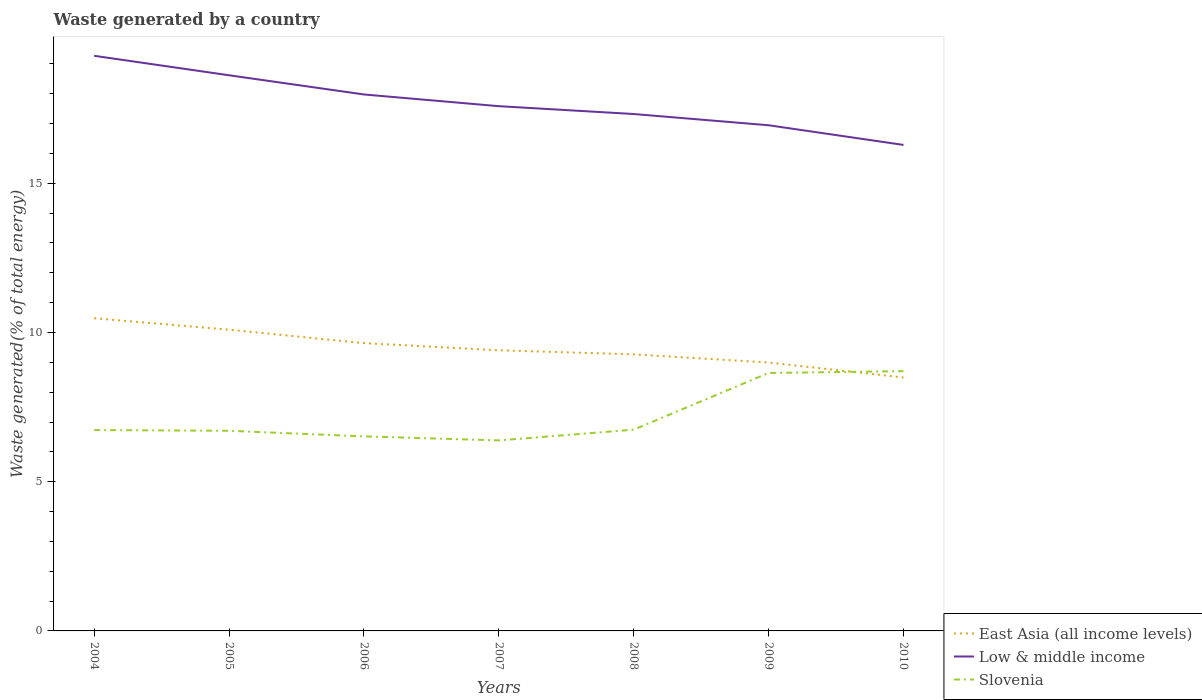Does the line corresponding to East Asia (all income levels) intersect with the line corresponding to Low & middle income?
Your response must be concise. No. Across all years, what is the maximum total waste generated in East Asia (all income levels)?
Your answer should be compact. 8.49. In which year was the total waste generated in Slovenia maximum?
Provide a short and direct response. 2007. What is the total total waste generated in Low & middle income in the graph?
Give a very brief answer. 0.38. What is the difference between the highest and the second highest total waste generated in East Asia (all income levels)?
Your answer should be very brief. 1.99. Is the total waste generated in East Asia (all income levels) strictly greater than the total waste generated in Low & middle income over the years?
Offer a very short reply. Yes. What is the difference between two consecutive major ticks on the Y-axis?
Provide a succinct answer. 5. Are the values on the major ticks of Y-axis written in scientific E-notation?
Make the answer very short. No. Does the graph contain any zero values?
Offer a terse response. No. Does the graph contain grids?
Ensure brevity in your answer.  No. What is the title of the graph?
Ensure brevity in your answer.  Waste generated by a country. Does "Turkey" appear as one of the legend labels in the graph?
Give a very brief answer. No. What is the label or title of the Y-axis?
Your response must be concise. Waste generated(% of total energy). What is the Waste generated(% of total energy) of East Asia (all income levels) in 2004?
Your response must be concise. 10.48. What is the Waste generated(% of total energy) of Low & middle income in 2004?
Ensure brevity in your answer.  19.27. What is the Waste generated(% of total energy) in Slovenia in 2004?
Offer a very short reply. 6.73. What is the Waste generated(% of total energy) of East Asia (all income levels) in 2005?
Ensure brevity in your answer.  10.09. What is the Waste generated(% of total energy) of Low & middle income in 2005?
Your answer should be very brief. 18.62. What is the Waste generated(% of total energy) in Slovenia in 2005?
Provide a succinct answer. 6.71. What is the Waste generated(% of total energy) of East Asia (all income levels) in 2006?
Offer a terse response. 9.64. What is the Waste generated(% of total energy) of Low & middle income in 2006?
Your answer should be very brief. 17.97. What is the Waste generated(% of total energy) of Slovenia in 2006?
Give a very brief answer. 6.52. What is the Waste generated(% of total energy) in East Asia (all income levels) in 2007?
Your response must be concise. 9.4. What is the Waste generated(% of total energy) in Low & middle income in 2007?
Ensure brevity in your answer.  17.58. What is the Waste generated(% of total energy) of Slovenia in 2007?
Make the answer very short. 6.38. What is the Waste generated(% of total energy) in East Asia (all income levels) in 2008?
Offer a terse response. 9.27. What is the Waste generated(% of total energy) of Low & middle income in 2008?
Your answer should be very brief. 17.32. What is the Waste generated(% of total energy) of Slovenia in 2008?
Your answer should be very brief. 6.74. What is the Waste generated(% of total energy) of East Asia (all income levels) in 2009?
Offer a very short reply. 8.99. What is the Waste generated(% of total energy) in Low & middle income in 2009?
Provide a succinct answer. 16.94. What is the Waste generated(% of total energy) of Slovenia in 2009?
Make the answer very short. 8.64. What is the Waste generated(% of total energy) of East Asia (all income levels) in 2010?
Provide a short and direct response. 8.49. What is the Waste generated(% of total energy) of Low & middle income in 2010?
Give a very brief answer. 16.28. What is the Waste generated(% of total energy) of Slovenia in 2010?
Provide a succinct answer. 8.7. Across all years, what is the maximum Waste generated(% of total energy) in East Asia (all income levels)?
Offer a terse response. 10.48. Across all years, what is the maximum Waste generated(% of total energy) in Low & middle income?
Give a very brief answer. 19.27. Across all years, what is the maximum Waste generated(% of total energy) of Slovenia?
Your answer should be compact. 8.7. Across all years, what is the minimum Waste generated(% of total energy) of East Asia (all income levels)?
Your response must be concise. 8.49. Across all years, what is the minimum Waste generated(% of total energy) of Low & middle income?
Offer a terse response. 16.28. Across all years, what is the minimum Waste generated(% of total energy) of Slovenia?
Your answer should be compact. 6.38. What is the total Waste generated(% of total energy) in East Asia (all income levels) in the graph?
Provide a succinct answer. 66.37. What is the total Waste generated(% of total energy) in Low & middle income in the graph?
Make the answer very short. 123.99. What is the total Waste generated(% of total energy) in Slovenia in the graph?
Offer a very short reply. 50.43. What is the difference between the Waste generated(% of total energy) of East Asia (all income levels) in 2004 and that in 2005?
Provide a short and direct response. 0.38. What is the difference between the Waste generated(% of total energy) of Low & middle income in 2004 and that in 2005?
Offer a terse response. 0.65. What is the difference between the Waste generated(% of total energy) of Slovenia in 2004 and that in 2005?
Your answer should be compact. 0.02. What is the difference between the Waste generated(% of total energy) of East Asia (all income levels) in 2004 and that in 2006?
Give a very brief answer. 0.83. What is the difference between the Waste generated(% of total energy) in Low & middle income in 2004 and that in 2006?
Your answer should be compact. 1.3. What is the difference between the Waste generated(% of total energy) of Slovenia in 2004 and that in 2006?
Your response must be concise. 0.21. What is the difference between the Waste generated(% of total energy) of East Asia (all income levels) in 2004 and that in 2007?
Your response must be concise. 1.07. What is the difference between the Waste generated(% of total energy) in Low & middle income in 2004 and that in 2007?
Provide a succinct answer. 1.69. What is the difference between the Waste generated(% of total energy) of Slovenia in 2004 and that in 2007?
Ensure brevity in your answer.  0.35. What is the difference between the Waste generated(% of total energy) in East Asia (all income levels) in 2004 and that in 2008?
Offer a very short reply. 1.21. What is the difference between the Waste generated(% of total energy) of Low & middle income in 2004 and that in 2008?
Provide a succinct answer. 1.95. What is the difference between the Waste generated(% of total energy) of Slovenia in 2004 and that in 2008?
Ensure brevity in your answer.  -0.01. What is the difference between the Waste generated(% of total energy) in East Asia (all income levels) in 2004 and that in 2009?
Keep it short and to the point. 1.48. What is the difference between the Waste generated(% of total energy) in Low & middle income in 2004 and that in 2009?
Make the answer very short. 2.33. What is the difference between the Waste generated(% of total energy) in Slovenia in 2004 and that in 2009?
Your answer should be compact. -1.91. What is the difference between the Waste generated(% of total energy) in East Asia (all income levels) in 2004 and that in 2010?
Offer a very short reply. 1.99. What is the difference between the Waste generated(% of total energy) in Low & middle income in 2004 and that in 2010?
Provide a short and direct response. 2.99. What is the difference between the Waste generated(% of total energy) of Slovenia in 2004 and that in 2010?
Offer a very short reply. -1.97. What is the difference between the Waste generated(% of total energy) in East Asia (all income levels) in 2005 and that in 2006?
Ensure brevity in your answer.  0.45. What is the difference between the Waste generated(% of total energy) in Low & middle income in 2005 and that in 2006?
Your response must be concise. 0.64. What is the difference between the Waste generated(% of total energy) in Slovenia in 2005 and that in 2006?
Give a very brief answer. 0.19. What is the difference between the Waste generated(% of total energy) of East Asia (all income levels) in 2005 and that in 2007?
Keep it short and to the point. 0.69. What is the difference between the Waste generated(% of total energy) of Low & middle income in 2005 and that in 2007?
Offer a terse response. 1.04. What is the difference between the Waste generated(% of total energy) in Slovenia in 2005 and that in 2007?
Offer a terse response. 0.32. What is the difference between the Waste generated(% of total energy) in East Asia (all income levels) in 2005 and that in 2008?
Your answer should be compact. 0.83. What is the difference between the Waste generated(% of total energy) of Low & middle income in 2005 and that in 2008?
Your answer should be very brief. 1.3. What is the difference between the Waste generated(% of total energy) in Slovenia in 2005 and that in 2008?
Make the answer very short. -0.04. What is the difference between the Waste generated(% of total energy) of East Asia (all income levels) in 2005 and that in 2009?
Your answer should be very brief. 1.1. What is the difference between the Waste generated(% of total energy) of Low & middle income in 2005 and that in 2009?
Keep it short and to the point. 1.67. What is the difference between the Waste generated(% of total energy) of Slovenia in 2005 and that in 2009?
Give a very brief answer. -1.94. What is the difference between the Waste generated(% of total energy) in East Asia (all income levels) in 2005 and that in 2010?
Your answer should be compact. 1.6. What is the difference between the Waste generated(% of total energy) in Low & middle income in 2005 and that in 2010?
Offer a very short reply. 2.33. What is the difference between the Waste generated(% of total energy) of Slovenia in 2005 and that in 2010?
Ensure brevity in your answer.  -2. What is the difference between the Waste generated(% of total energy) of East Asia (all income levels) in 2006 and that in 2007?
Provide a short and direct response. 0.24. What is the difference between the Waste generated(% of total energy) of Low & middle income in 2006 and that in 2007?
Give a very brief answer. 0.39. What is the difference between the Waste generated(% of total energy) in Slovenia in 2006 and that in 2007?
Offer a terse response. 0.14. What is the difference between the Waste generated(% of total energy) of East Asia (all income levels) in 2006 and that in 2008?
Keep it short and to the point. 0.38. What is the difference between the Waste generated(% of total energy) of Low & middle income in 2006 and that in 2008?
Offer a terse response. 0.66. What is the difference between the Waste generated(% of total energy) of Slovenia in 2006 and that in 2008?
Provide a succinct answer. -0.23. What is the difference between the Waste generated(% of total energy) of East Asia (all income levels) in 2006 and that in 2009?
Make the answer very short. 0.65. What is the difference between the Waste generated(% of total energy) in Low & middle income in 2006 and that in 2009?
Make the answer very short. 1.03. What is the difference between the Waste generated(% of total energy) of Slovenia in 2006 and that in 2009?
Provide a succinct answer. -2.12. What is the difference between the Waste generated(% of total energy) of East Asia (all income levels) in 2006 and that in 2010?
Provide a short and direct response. 1.15. What is the difference between the Waste generated(% of total energy) of Low & middle income in 2006 and that in 2010?
Give a very brief answer. 1.69. What is the difference between the Waste generated(% of total energy) of Slovenia in 2006 and that in 2010?
Ensure brevity in your answer.  -2.19. What is the difference between the Waste generated(% of total energy) in East Asia (all income levels) in 2007 and that in 2008?
Ensure brevity in your answer.  0.14. What is the difference between the Waste generated(% of total energy) in Low & middle income in 2007 and that in 2008?
Provide a short and direct response. 0.26. What is the difference between the Waste generated(% of total energy) of Slovenia in 2007 and that in 2008?
Offer a terse response. -0.36. What is the difference between the Waste generated(% of total energy) of East Asia (all income levels) in 2007 and that in 2009?
Make the answer very short. 0.41. What is the difference between the Waste generated(% of total energy) of Low & middle income in 2007 and that in 2009?
Keep it short and to the point. 0.64. What is the difference between the Waste generated(% of total energy) of Slovenia in 2007 and that in 2009?
Your answer should be very brief. -2.26. What is the difference between the Waste generated(% of total energy) of East Asia (all income levels) in 2007 and that in 2010?
Your response must be concise. 0.91. What is the difference between the Waste generated(% of total energy) in Low & middle income in 2007 and that in 2010?
Your response must be concise. 1.3. What is the difference between the Waste generated(% of total energy) of Slovenia in 2007 and that in 2010?
Make the answer very short. -2.32. What is the difference between the Waste generated(% of total energy) of East Asia (all income levels) in 2008 and that in 2009?
Your response must be concise. 0.27. What is the difference between the Waste generated(% of total energy) in Low & middle income in 2008 and that in 2009?
Give a very brief answer. 0.38. What is the difference between the Waste generated(% of total energy) of Slovenia in 2008 and that in 2009?
Your response must be concise. -1.9. What is the difference between the Waste generated(% of total energy) in East Asia (all income levels) in 2008 and that in 2010?
Your answer should be compact. 0.78. What is the difference between the Waste generated(% of total energy) of Low & middle income in 2008 and that in 2010?
Ensure brevity in your answer.  1.03. What is the difference between the Waste generated(% of total energy) in Slovenia in 2008 and that in 2010?
Give a very brief answer. -1.96. What is the difference between the Waste generated(% of total energy) in East Asia (all income levels) in 2009 and that in 2010?
Your answer should be compact. 0.5. What is the difference between the Waste generated(% of total energy) of Low & middle income in 2009 and that in 2010?
Make the answer very short. 0.66. What is the difference between the Waste generated(% of total energy) in Slovenia in 2009 and that in 2010?
Give a very brief answer. -0.06. What is the difference between the Waste generated(% of total energy) of East Asia (all income levels) in 2004 and the Waste generated(% of total energy) of Low & middle income in 2005?
Your answer should be compact. -8.14. What is the difference between the Waste generated(% of total energy) of East Asia (all income levels) in 2004 and the Waste generated(% of total energy) of Slovenia in 2005?
Give a very brief answer. 3.77. What is the difference between the Waste generated(% of total energy) of Low & middle income in 2004 and the Waste generated(% of total energy) of Slovenia in 2005?
Ensure brevity in your answer.  12.56. What is the difference between the Waste generated(% of total energy) in East Asia (all income levels) in 2004 and the Waste generated(% of total energy) in Low & middle income in 2006?
Your response must be concise. -7.5. What is the difference between the Waste generated(% of total energy) of East Asia (all income levels) in 2004 and the Waste generated(% of total energy) of Slovenia in 2006?
Give a very brief answer. 3.96. What is the difference between the Waste generated(% of total energy) in Low & middle income in 2004 and the Waste generated(% of total energy) in Slovenia in 2006?
Your answer should be very brief. 12.75. What is the difference between the Waste generated(% of total energy) of East Asia (all income levels) in 2004 and the Waste generated(% of total energy) of Low & middle income in 2007?
Offer a terse response. -7.11. What is the difference between the Waste generated(% of total energy) of East Asia (all income levels) in 2004 and the Waste generated(% of total energy) of Slovenia in 2007?
Your response must be concise. 4.09. What is the difference between the Waste generated(% of total energy) of Low & middle income in 2004 and the Waste generated(% of total energy) of Slovenia in 2007?
Provide a short and direct response. 12.89. What is the difference between the Waste generated(% of total energy) of East Asia (all income levels) in 2004 and the Waste generated(% of total energy) of Low & middle income in 2008?
Make the answer very short. -6.84. What is the difference between the Waste generated(% of total energy) in East Asia (all income levels) in 2004 and the Waste generated(% of total energy) in Slovenia in 2008?
Offer a terse response. 3.73. What is the difference between the Waste generated(% of total energy) in Low & middle income in 2004 and the Waste generated(% of total energy) in Slovenia in 2008?
Offer a terse response. 12.53. What is the difference between the Waste generated(% of total energy) in East Asia (all income levels) in 2004 and the Waste generated(% of total energy) in Low & middle income in 2009?
Your answer should be compact. -6.47. What is the difference between the Waste generated(% of total energy) of East Asia (all income levels) in 2004 and the Waste generated(% of total energy) of Slovenia in 2009?
Provide a short and direct response. 1.83. What is the difference between the Waste generated(% of total energy) of Low & middle income in 2004 and the Waste generated(% of total energy) of Slovenia in 2009?
Give a very brief answer. 10.63. What is the difference between the Waste generated(% of total energy) of East Asia (all income levels) in 2004 and the Waste generated(% of total energy) of Low & middle income in 2010?
Offer a terse response. -5.81. What is the difference between the Waste generated(% of total energy) in East Asia (all income levels) in 2004 and the Waste generated(% of total energy) in Slovenia in 2010?
Make the answer very short. 1.77. What is the difference between the Waste generated(% of total energy) of Low & middle income in 2004 and the Waste generated(% of total energy) of Slovenia in 2010?
Your response must be concise. 10.57. What is the difference between the Waste generated(% of total energy) in East Asia (all income levels) in 2005 and the Waste generated(% of total energy) in Low & middle income in 2006?
Keep it short and to the point. -7.88. What is the difference between the Waste generated(% of total energy) of East Asia (all income levels) in 2005 and the Waste generated(% of total energy) of Slovenia in 2006?
Your response must be concise. 3.57. What is the difference between the Waste generated(% of total energy) in Low & middle income in 2005 and the Waste generated(% of total energy) in Slovenia in 2006?
Keep it short and to the point. 12.1. What is the difference between the Waste generated(% of total energy) of East Asia (all income levels) in 2005 and the Waste generated(% of total energy) of Low & middle income in 2007?
Your answer should be compact. -7.49. What is the difference between the Waste generated(% of total energy) in East Asia (all income levels) in 2005 and the Waste generated(% of total energy) in Slovenia in 2007?
Offer a terse response. 3.71. What is the difference between the Waste generated(% of total energy) in Low & middle income in 2005 and the Waste generated(% of total energy) in Slovenia in 2007?
Your answer should be very brief. 12.23. What is the difference between the Waste generated(% of total energy) in East Asia (all income levels) in 2005 and the Waste generated(% of total energy) in Low & middle income in 2008?
Make the answer very short. -7.23. What is the difference between the Waste generated(% of total energy) of East Asia (all income levels) in 2005 and the Waste generated(% of total energy) of Slovenia in 2008?
Your answer should be very brief. 3.35. What is the difference between the Waste generated(% of total energy) of Low & middle income in 2005 and the Waste generated(% of total energy) of Slovenia in 2008?
Your response must be concise. 11.87. What is the difference between the Waste generated(% of total energy) of East Asia (all income levels) in 2005 and the Waste generated(% of total energy) of Low & middle income in 2009?
Provide a short and direct response. -6.85. What is the difference between the Waste generated(% of total energy) of East Asia (all income levels) in 2005 and the Waste generated(% of total energy) of Slovenia in 2009?
Your answer should be compact. 1.45. What is the difference between the Waste generated(% of total energy) in Low & middle income in 2005 and the Waste generated(% of total energy) in Slovenia in 2009?
Ensure brevity in your answer.  9.97. What is the difference between the Waste generated(% of total energy) of East Asia (all income levels) in 2005 and the Waste generated(% of total energy) of Low & middle income in 2010?
Offer a very short reply. -6.19. What is the difference between the Waste generated(% of total energy) in East Asia (all income levels) in 2005 and the Waste generated(% of total energy) in Slovenia in 2010?
Offer a very short reply. 1.39. What is the difference between the Waste generated(% of total energy) in Low & middle income in 2005 and the Waste generated(% of total energy) in Slovenia in 2010?
Make the answer very short. 9.91. What is the difference between the Waste generated(% of total energy) in East Asia (all income levels) in 2006 and the Waste generated(% of total energy) in Low & middle income in 2007?
Your answer should be very brief. -7.94. What is the difference between the Waste generated(% of total energy) of East Asia (all income levels) in 2006 and the Waste generated(% of total energy) of Slovenia in 2007?
Provide a short and direct response. 3.26. What is the difference between the Waste generated(% of total energy) in Low & middle income in 2006 and the Waste generated(% of total energy) in Slovenia in 2007?
Your answer should be compact. 11.59. What is the difference between the Waste generated(% of total energy) in East Asia (all income levels) in 2006 and the Waste generated(% of total energy) in Low & middle income in 2008?
Ensure brevity in your answer.  -7.68. What is the difference between the Waste generated(% of total energy) of East Asia (all income levels) in 2006 and the Waste generated(% of total energy) of Slovenia in 2008?
Keep it short and to the point. 2.9. What is the difference between the Waste generated(% of total energy) in Low & middle income in 2006 and the Waste generated(% of total energy) in Slovenia in 2008?
Offer a terse response. 11.23. What is the difference between the Waste generated(% of total energy) of East Asia (all income levels) in 2006 and the Waste generated(% of total energy) of Low & middle income in 2009?
Make the answer very short. -7.3. What is the difference between the Waste generated(% of total energy) of East Asia (all income levels) in 2006 and the Waste generated(% of total energy) of Slovenia in 2009?
Provide a short and direct response. 1. What is the difference between the Waste generated(% of total energy) of Low & middle income in 2006 and the Waste generated(% of total energy) of Slovenia in 2009?
Provide a short and direct response. 9.33. What is the difference between the Waste generated(% of total energy) of East Asia (all income levels) in 2006 and the Waste generated(% of total energy) of Low & middle income in 2010?
Your response must be concise. -6.64. What is the difference between the Waste generated(% of total energy) of East Asia (all income levels) in 2006 and the Waste generated(% of total energy) of Slovenia in 2010?
Ensure brevity in your answer.  0.94. What is the difference between the Waste generated(% of total energy) in Low & middle income in 2006 and the Waste generated(% of total energy) in Slovenia in 2010?
Give a very brief answer. 9.27. What is the difference between the Waste generated(% of total energy) in East Asia (all income levels) in 2007 and the Waste generated(% of total energy) in Low & middle income in 2008?
Keep it short and to the point. -7.92. What is the difference between the Waste generated(% of total energy) of East Asia (all income levels) in 2007 and the Waste generated(% of total energy) of Slovenia in 2008?
Give a very brief answer. 2.66. What is the difference between the Waste generated(% of total energy) in Low & middle income in 2007 and the Waste generated(% of total energy) in Slovenia in 2008?
Offer a terse response. 10.84. What is the difference between the Waste generated(% of total energy) of East Asia (all income levels) in 2007 and the Waste generated(% of total energy) of Low & middle income in 2009?
Your answer should be compact. -7.54. What is the difference between the Waste generated(% of total energy) in East Asia (all income levels) in 2007 and the Waste generated(% of total energy) in Slovenia in 2009?
Ensure brevity in your answer.  0.76. What is the difference between the Waste generated(% of total energy) in Low & middle income in 2007 and the Waste generated(% of total energy) in Slovenia in 2009?
Provide a succinct answer. 8.94. What is the difference between the Waste generated(% of total energy) of East Asia (all income levels) in 2007 and the Waste generated(% of total energy) of Low & middle income in 2010?
Ensure brevity in your answer.  -6.88. What is the difference between the Waste generated(% of total energy) of East Asia (all income levels) in 2007 and the Waste generated(% of total energy) of Slovenia in 2010?
Provide a short and direct response. 0.7. What is the difference between the Waste generated(% of total energy) in Low & middle income in 2007 and the Waste generated(% of total energy) in Slovenia in 2010?
Your response must be concise. 8.88. What is the difference between the Waste generated(% of total energy) in East Asia (all income levels) in 2008 and the Waste generated(% of total energy) in Low & middle income in 2009?
Provide a short and direct response. -7.68. What is the difference between the Waste generated(% of total energy) of East Asia (all income levels) in 2008 and the Waste generated(% of total energy) of Slovenia in 2009?
Offer a very short reply. 0.62. What is the difference between the Waste generated(% of total energy) in Low & middle income in 2008 and the Waste generated(% of total energy) in Slovenia in 2009?
Your answer should be compact. 8.68. What is the difference between the Waste generated(% of total energy) of East Asia (all income levels) in 2008 and the Waste generated(% of total energy) of Low & middle income in 2010?
Provide a succinct answer. -7.02. What is the difference between the Waste generated(% of total energy) of East Asia (all income levels) in 2008 and the Waste generated(% of total energy) of Slovenia in 2010?
Make the answer very short. 0.56. What is the difference between the Waste generated(% of total energy) in Low & middle income in 2008 and the Waste generated(% of total energy) in Slovenia in 2010?
Offer a terse response. 8.61. What is the difference between the Waste generated(% of total energy) of East Asia (all income levels) in 2009 and the Waste generated(% of total energy) of Low & middle income in 2010?
Your response must be concise. -7.29. What is the difference between the Waste generated(% of total energy) in East Asia (all income levels) in 2009 and the Waste generated(% of total energy) in Slovenia in 2010?
Your answer should be very brief. 0.29. What is the difference between the Waste generated(% of total energy) in Low & middle income in 2009 and the Waste generated(% of total energy) in Slovenia in 2010?
Ensure brevity in your answer.  8.24. What is the average Waste generated(% of total energy) of East Asia (all income levels) per year?
Ensure brevity in your answer.  9.48. What is the average Waste generated(% of total energy) in Low & middle income per year?
Offer a terse response. 17.71. What is the average Waste generated(% of total energy) in Slovenia per year?
Offer a terse response. 7.2. In the year 2004, what is the difference between the Waste generated(% of total energy) in East Asia (all income levels) and Waste generated(% of total energy) in Low & middle income?
Keep it short and to the point. -8.79. In the year 2004, what is the difference between the Waste generated(% of total energy) of East Asia (all income levels) and Waste generated(% of total energy) of Slovenia?
Keep it short and to the point. 3.75. In the year 2004, what is the difference between the Waste generated(% of total energy) of Low & middle income and Waste generated(% of total energy) of Slovenia?
Offer a terse response. 12.54. In the year 2005, what is the difference between the Waste generated(% of total energy) in East Asia (all income levels) and Waste generated(% of total energy) in Low & middle income?
Your response must be concise. -8.52. In the year 2005, what is the difference between the Waste generated(% of total energy) in East Asia (all income levels) and Waste generated(% of total energy) in Slovenia?
Make the answer very short. 3.39. In the year 2005, what is the difference between the Waste generated(% of total energy) of Low & middle income and Waste generated(% of total energy) of Slovenia?
Keep it short and to the point. 11.91. In the year 2006, what is the difference between the Waste generated(% of total energy) of East Asia (all income levels) and Waste generated(% of total energy) of Low & middle income?
Give a very brief answer. -8.33. In the year 2006, what is the difference between the Waste generated(% of total energy) of East Asia (all income levels) and Waste generated(% of total energy) of Slovenia?
Provide a succinct answer. 3.12. In the year 2006, what is the difference between the Waste generated(% of total energy) in Low & middle income and Waste generated(% of total energy) in Slovenia?
Offer a very short reply. 11.46. In the year 2007, what is the difference between the Waste generated(% of total energy) in East Asia (all income levels) and Waste generated(% of total energy) in Low & middle income?
Offer a terse response. -8.18. In the year 2007, what is the difference between the Waste generated(% of total energy) of East Asia (all income levels) and Waste generated(% of total energy) of Slovenia?
Offer a very short reply. 3.02. In the year 2007, what is the difference between the Waste generated(% of total energy) of Low & middle income and Waste generated(% of total energy) of Slovenia?
Provide a succinct answer. 11.2. In the year 2008, what is the difference between the Waste generated(% of total energy) in East Asia (all income levels) and Waste generated(% of total energy) in Low & middle income?
Provide a succinct answer. -8.05. In the year 2008, what is the difference between the Waste generated(% of total energy) of East Asia (all income levels) and Waste generated(% of total energy) of Slovenia?
Your answer should be compact. 2.52. In the year 2008, what is the difference between the Waste generated(% of total energy) in Low & middle income and Waste generated(% of total energy) in Slovenia?
Give a very brief answer. 10.58. In the year 2009, what is the difference between the Waste generated(% of total energy) in East Asia (all income levels) and Waste generated(% of total energy) in Low & middle income?
Your answer should be very brief. -7.95. In the year 2009, what is the difference between the Waste generated(% of total energy) in East Asia (all income levels) and Waste generated(% of total energy) in Slovenia?
Keep it short and to the point. 0.35. In the year 2009, what is the difference between the Waste generated(% of total energy) in Low & middle income and Waste generated(% of total energy) in Slovenia?
Your answer should be compact. 8.3. In the year 2010, what is the difference between the Waste generated(% of total energy) of East Asia (all income levels) and Waste generated(% of total energy) of Low & middle income?
Give a very brief answer. -7.79. In the year 2010, what is the difference between the Waste generated(% of total energy) in East Asia (all income levels) and Waste generated(% of total energy) in Slovenia?
Provide a succinct answer. -0.21. In the year 2010, what is the difference between the Waste generated(% of total energy) in Low & middle income and Waste generated(% of total energy) in Slovenia?
Make the answer very short. 7.58. What is the ratio of the Waste generated(% of total energy) of East Asia (all income levels) in 2004 to that in 2005?
Ensure brevity in your answer.  1.04. What is the ratio of the Waste generated(% of total energy) in Low & middle income in 2004 to that in 2005?
Make the answer very short. 1.03. What is the ratio of the Waste generated(% of total energy) in East Asia (all income levels) in 2004 to that in 2006?
Keep it short and to the point. 1.09. What is the ratio of the Waste generated(% of total energy) of Low & middle income in 2004 to that in 2006?
Your answer should be compact. 1.07. What is the ratio of the Waste generated(% of total energy) in Slovenia in 2004 to that in 2006?
Keep it short and to the point. 1.03. What is the ratio of the Waste generated(% of total energy) in East Asia (all income levels) in 2004 to that in 2007?
Provide a short and direct response. 1.11. What is the ratio of the Waste generated(% of total energy) of Low & middle income in 2004 to that in 2007?
Make the answer very short. 1.1. What is the ratio of the Waste generated(% of total energy) in Slovenia in 2004 to that in 2007?
Your response must be concise. 1.05. What is the ratio of the Waste generated(% of total energy) in East Asia (all income levels) in 2004 to that in 2008?
Provide a short and direct response. 1.13. What is the ratio of the Waste generated(% of total energy) of Low & middle income in 2004 to that in 2008?
Give a very brief answer. 1.11. What is the ratio of the Waste generated(% of total energy) in East Asia (all income levels) in 2004 to that in 2009?
Provide a succinct answer. 1.17. What is the ratio of the Waste generated(% of total energy) in Low & middle income in 2004 to that in 2009?
Provide a succinct answer. 1.14. What is the ratio of the Waste generated(% of total energy) in Slovenia in 2004 to that in 2009?
Your answer should be very brief. 0.78. What is the ratio of the Waste generated(% of total energy) of East Asia (all income levels) in 2004 to that in 2010?
Give a very brief answer. 1.23. What is the ratio of the Waste generated(% of total energy) in Low & middle income in 2004 to that in 2010?
Provide a short and direct response. 1.18. What is the ratio of the Waste generated(% of total energy) in Slovenia in 2004 to that in 2010?
Provide a short and direct response. 0.77. What is the ratio of the Waste generated(% of total energy) of East Asia (all income levels) in 2005 to that in 2006?
Your answer should be very brief. 1.05. What is the ratio of the Waste generated(% of total energy) in Low & middle income in 2005 to that in 2006?
Keep it short and to the point. 1.04. What is the ratio of the Waste generated(% of total energy) of Slovenia in 2005 to that in 2006?
Offer a terse response. 1.03. What is the ratio of the Waste generated(% of total energy) in East Asia (all income levels) in 2005 to that in 2007?
Provide a short and direct response. 1.07. What is the ratio of the Waste generated(% of total energy) in Low & middle income in 2005 to that in 2007?
Your answer should be compact. 1.06. What is the ratio of the Waste generated(% of total energy) of Slovenia in 2005 to that in 2007?
Offer a very short reply. 1.05. What is the ratio of the Waste generated(% of total energy) in East Asia (all income levels) in 2005 to that in 2008?
Offer a terse response. 1.09. What is the ratio of the Waste generated(% of total energy) in Low & middle income in 2005 to that in 2008?
Your answer should be very brief. 1.07. What is the ratio of the Waste generated(% of total energy) in Slovenia in 2005 to that in 2008?
Keep it short and to the point. 0.99. What is the ratio of the Waste generated(% of total energy) in East Asia (all income levels) in 2005 to that in 2009?
Keep it short and to the point. 1.12. What is the ratio of the Waste generated(% of total energy) in Low & middle income in 2005 to that in 2009?
Give a very brief answer. 1.1. What is the ratio of the Waste generated(% of total energy) of Slovenia in 2005 to that in 2009?
Ensure brevity in your answer.  0.78. What is the ratio of the Waste generated(% of total energy) in East Asia (all income levels) in 2005 to that in 2010?
Provide a succinct answer. 1.19. What is the ratio of the Waste generated(% of total energy) of Low & middle income in 2005 to that in 2010?
Provide a short and direct response. 1.14. What is the ratio of the Waste generated(% of total energy) of Slovenia in 2005 to that in 2010?
Give a very brief answer. 0.77. What is the ratio of the Waste generated(% of total energy) of East Asia (all income levels) in 2006 to that in 2007?
Keep it short and to the point. 1.03. What is the ratio of the Waste generated(% of total energy) of Low & middle income in 2006 to that in 2007?
Your answer should be very brief. 1.02. What is the ratio of the Waste generated(% of total energy) in Slovenia in 2006 to that in 2007?
Your response must be concise. 1.02. What is the ratio of the Waste generated(% of total energy) in East Asia (all income levels) in 2006 to that in 2008?
Your answer should be very brief. 1.04. What is the ratio of the Waste generated(% of total energy) of Low & middle income in 2006 to that in 2008?
Provide a succinct answer. 1.04. What is the ratio of the Waste generated(% of total energy) of Slovenia in 2006 to that in 2008?
Your response must be concise. 0.97. What is the ratio of the Waste generated(% of total energy) in East Asia (all income levels) in 2006 to that in 2009?
Your response must be concise. 1.07. What is the ratio of the Waste generated(% of total energy) of Low & middle income in 2006 to that in 2009?
Provide a short and direct response. 1.06. What is the ratio of the Waste generated(% of total energy) of Slovenia in 2006 to that in 2009?
Your answer should be compact. 0.75. What is the ratio of the Waste generated(% of total energy) in East Asia (all income levels) in 2006 to that in 2010?
Ensure brevity in your answer.  1.14. What is the ratio of the Waste generated(% of total energy) of Low & middle income in 2006 to that in 2010?
Provide a short and direct response. 1.1. What is the ratio of the Waste generated(% of total energy) of Slovenia in 2006 to that in 2010?
Provide a succinct answer. 0.75. What is the ratio of the Waste generated(% of total energy) in East Asia (all income levels) in 2007 to that in 2008?
Give a very brief answer. 1.01. What is the ratio of the Waste generated(% of total energy) in Low & middle income in 2007 to that in 2008?
Give a very brief answer. 1.02. What is the ratio of the Waste generated(% of total energy) of Slovenia in 2007 to that in 2008?
Keep it short and to the point. 0.95. What is the ratio of the Waste generated(% of total energy) in East Asia (all income levels) in 2007 to that in 2009?
Give a very brief answer. 1.05. What is the ratio of the Waste generated(% of total energy) of Low & middle income in 2007 to that in 2009?
Keep it short and to the point. 1.04. What is the ratio of the Waste generated(% of total energy) of Slovenia in 2007 to that in 2009?
Offer a terse response. 0.74. What is the ratio of the Waste generated(% of total energy) in East Asia (all income levels) in 2007 to that in 2010?
Keep it short and to the point. 1.11. What is the ratio of the Waste generated(% of total energy) of Low & middle income in 2007 to that in 2010?
Your response must be concise. 1.08. What is the ratio of the Waste generated(% of total energy) of Slovenia in 2007 to that in 2010?
Offer a terse response. 0.73. What is the ratio of the Waste generated(% of total energy) of East Asia (all income levels) in 2008 to that in 2009?
Make the answer very short. 1.03. What is the ratio of the Waste generated(% of total energy) in Low & middle income in 2008 to that in 2009?
Your answer should be compact. 1.02. What is the ratio of the Waste generated(% of total energy) in Slovenia in 2008 to that in 2009?
Your answer should be compact. 0.78. What is the ratio of the Waste generated(% of total energy) of East Asia (all income levels) in 2008 to that in 2010?
Ensure brevity in your answer.  1.09. What is the ratio of the Waste generated(% of total energy) of Low & middle income in 2008 to that in 2010?
Keep it short and to the point. 1.06. What is the ratio of the Waste generated(% of total energy) of Slovenia in 2008 to that in 2010?
Your response must be concise. 0.77. What is the ratio of the Waste generated(% of total energy) of East Asia (all income levels) in 2009 to that in 2010?
Keep it short and to the point. 1.06. What is the ratio of the Waste generated(% of total energy) in Low & middle income in 2009 to that in 2010?
Make the answer very short. 1.04. What is the ratio of the Waste generated(% of total energy) in Slovenia in 2009 to that in 2010?
Your answer should be very brief. 0.99. What is the difference between the highest and the second highest Waste generated(% of total energy) in East Asia (all income levels)?
Your response must be concise. 0.38. What is the difference between the highest and the second highest Waste generated(% of total energy) in Low & middle income?
Give a very brief answer. 0.65. What is the difference between the highest and the second highest Waste generated(% of total energy) of Slovenia?
Give a very brief answer. 0.06. What is the difference between the highest and the lowest Waste generated(% of total energy) in East Asia (all income levels)?
Offer a terse response. 1.99. What is the difference between the highest and the lowest Waste generated(% of total energy) in Low & middle income?
Your answer should be very brief. 2.99. What is the difference between the highest and the lowest Waste generated(% of total energy) of Slovenia?
Give a very brief answer. 2.32. 